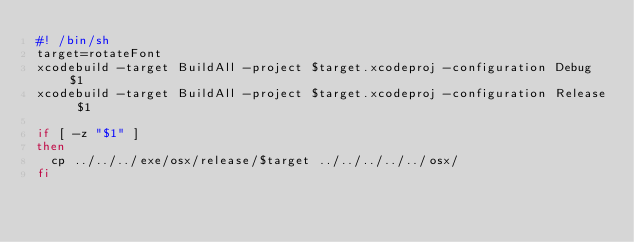Convert code to text. <code><loc_0><loc_0><loc_500><loc_500><_Bash_>#! /bin/sh
target=rotateFont
xcodebuild -target BuildAll -project $target.xcodeproj -configuration Debug $1
xcodebuild -target BuildAll -project $target.xcodeproj -configuration Release $1

if [ -z "$1" ]
then
	cp ../../../exe/osx/release/$target ../../../../../osx/
fi
</code> 